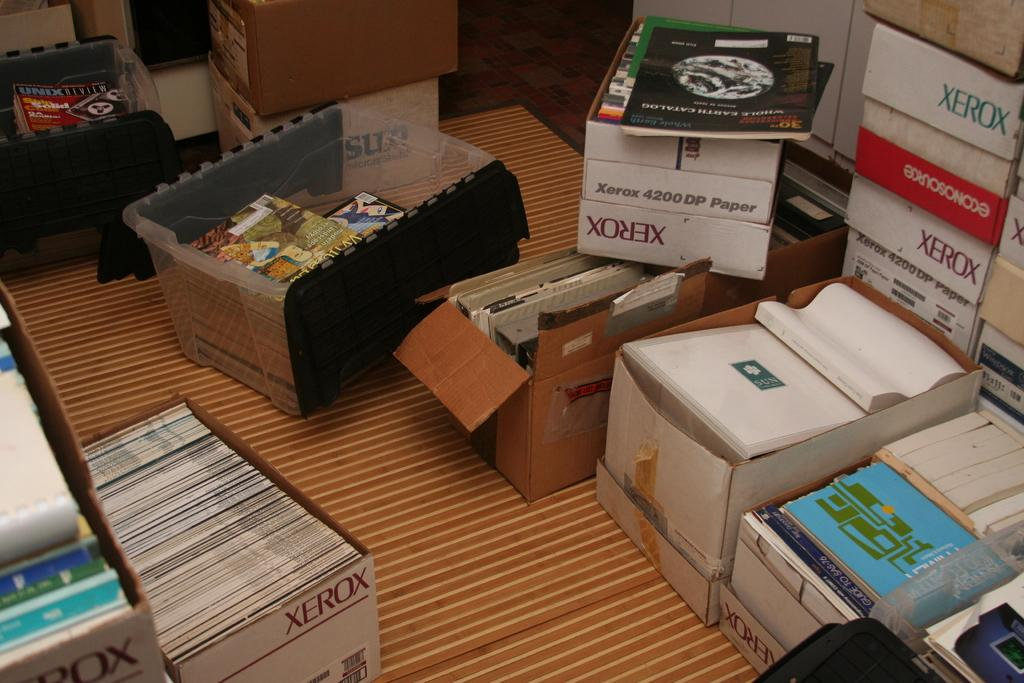What is located in the center of the image? There are boxes with objects in the center of the image. What type of flooring is visible at the bottom of the image? There is a carpet at the bottom of the image. How many lizards can be seen crawling on the carpet in the image? There are no lizards present in the image; it only features boxes with objects and a carpet. What type of beast is depicted on the boxes in the image? There is no beast depicted on the boxes in the image; they are just boxes with objects. 